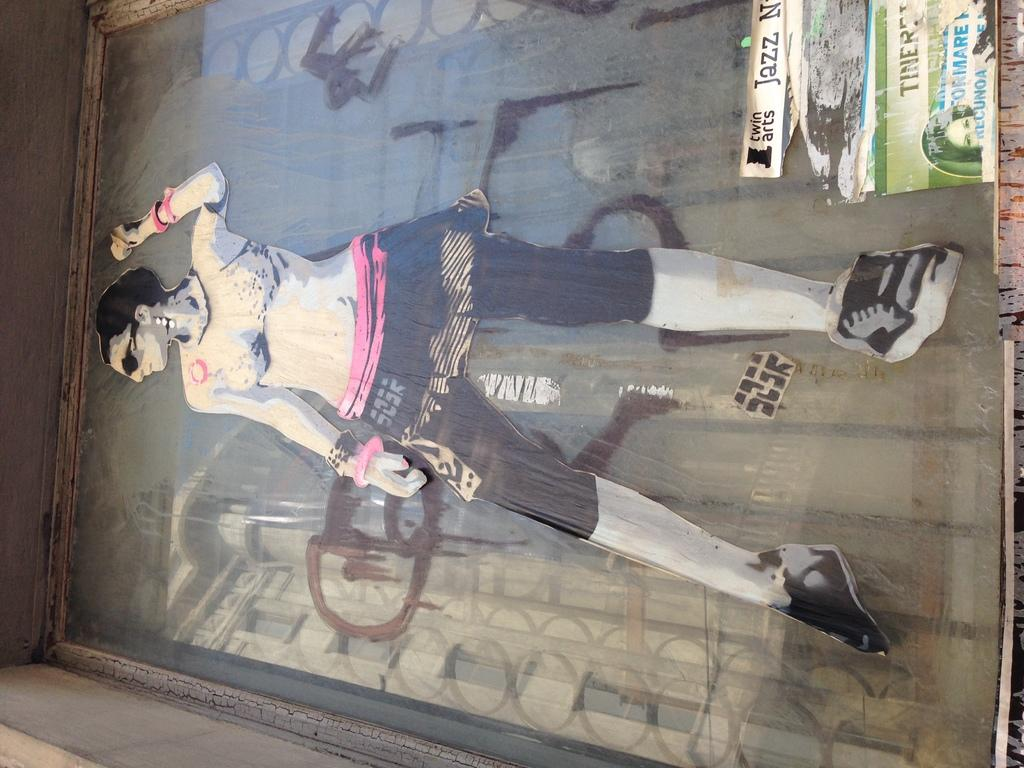What is depicted in the painting in the image? There is a painting of a person in the image. How is the painting displayed in the image? The painting is in a photo frame. What else can be seen in the image besides the painting? There is some text in the image. How many cats are visible in the image? There are no cats present in the image. What is the person in the painting copying in the image? The person in the painting is not depicted as copying anything in the image. 